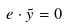Convert formula to latex. <formula><loc_0><loc_0><loc_500><loc_500>e \cdot \tilde { y } = 0</formula> 